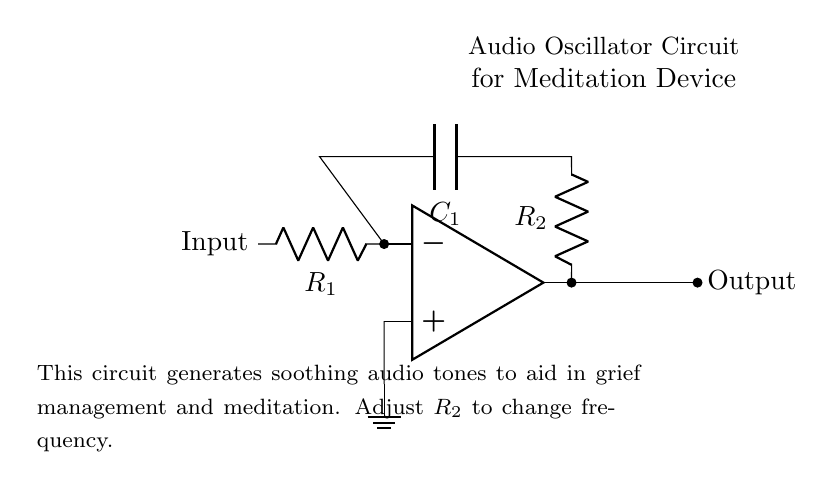What is the input component of this circuit? The input component is indicated on the left side of the diagram and is labeled as "Input". It leads into the inverting input of the operational amplifier.
Answer: Input What does the capacitor in this circuit do? The capacitor, labeled as C1, connects to the output of the operational amplifier and creates a feedback loop. In an oscillator circuit, it helps determine the frequency of the generated audio signals by combining with the resistor R2.
Answer: Determines frequency How can you change the frequency of the audio output? The frequency of the output signal can be altered by adjusting the resistance of the resistor labeled R2. By increasing or decreasing R2's value, the timing of the oscillation changes, which affects the frequency.
Answer: Adjust R2 What type of circuit is this? This circuit is specifically an audio oscillator, which is designed to generate sound waves at a particular frequency for therapeutic purposes, particularly in meditation.
Answer: Audio oscillator What are the main components in this oscillator circuit? The main components include an operational amplifier, two resistors (R1 and R2), and a capacitor (C1). Each of these plays a crucial role in generating the audio signals.
Answer: Op amp, R1, R2, C1 